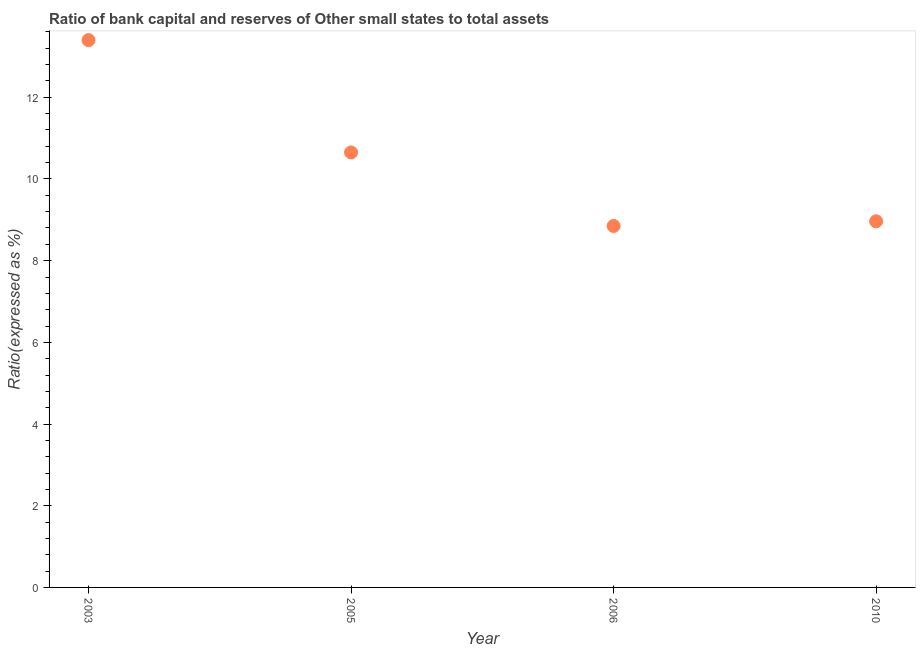What is the bank capital to assets ratio in 2006?
Give a very brief answer. 8.85. Across all years, what is the minimum bank capital to assets ratio?
Offer a terse response. 8.85. What is the sum of the bank capital to assets ratio?
Give a very brief answer. 41.86. What is the difference between the bank capital to assets ratio in 2005 and 2010?
Make the answer very short. 1.69. What is the average bank capital to assets ratio per year?
Your answer should be very brief. 10.47. What is the median bank capital to assets ratio?
Keep it short and to the point. 9.81. What is the ratio of the bank capital to assets ratio in 2005 to that in 2010?
Keep it short and to the point. 1.19. Is the bank capital to assets ratio in 2006 less than that in 2010?
Ensure brevity in your answer.  Yes. Is the difference between the bank capital to assets ratio in 2005 and 2010 greater than the difference between any two years?
Provide a short and direct response. No. What is the difference between the highest and the second highest bank capital to assets ratio?
Offer a terse response. 2.75. Is the sum of the bank capital to assets ratio in 2005 and 2010 greater than the maximum bank capital to assets ratio across all years?
Your response must be concise. Yes. What is the difference between the highest and the lowest bank capital to assets ratio?
Your answer should be very brief. 4.55. Does the bank capital to assets ratio monotonically increase over the years?
Keep it short and to the point. No. How many dotlines are there?
Make the answer very short. 1. Does the graph contain grids?
Ensure brevity in your answer.  No. What is the title of the graph?
Make the answer very short. Ratio of bank capital and reserves of Other small states to total assets. What is the label or title of the X-axis?
Your response must be concise. Year. What is the label or title of the Y-axis?
Make the answer very short. Ratio(expressed as %). What is the Ratio(expressed as %) in 2005?
Your answer should be compact. 10.65. What is the Ratio(expressed as %) in 2006?
Give a very brief answer. 8.85. What is the Ratio(expressed as %) in 2010?
Keep it short and to the point. 8.96. What is the difference between the Ratio(expressed as %) in 2003 and 2005?
Offer a terse response. 2.75. What is the difference between the Ratio(expressed as %) in 2003 and 2006?
Your answer should be compact. 4.55. What is the difference between the Ratio(expressed as %) in 2003 and 2010?
Your response must be concise. 4.44. What is the difference between the Ratio(expressed as %) in 2005 and 2006?
Provide a short and direct response. 1.8. What is the difference between the Ratio(expressed as %) in 2005 and 2010?
Provide a short and direct response. 1.69. What is the difference between the Ratio(expressed as %) in 2006 and 2010?
Your answer should be very brief. -0.11. What is the ratio of the Ratio(expressed as %) in 2003 to that in 2005?
Your response must be concise. 1.26. What is the ratio of the Ratio(expressed as %) in 2003 to that in 2006?
Provide a short and direct response. 1.51. What is the ratio of the Ratio(expressed as %) in 2003 to that in 2010?
Ensure brevity in your answer.  1.5. What is the ratio of the Ratio(expressed as %) in 2005 to that in 2006?
Offer a terse response. 1.2. What is the ratio of the Ratio(expressed as %) in 2005 to that in 2010?
Offer a very short reply. 1.19. 